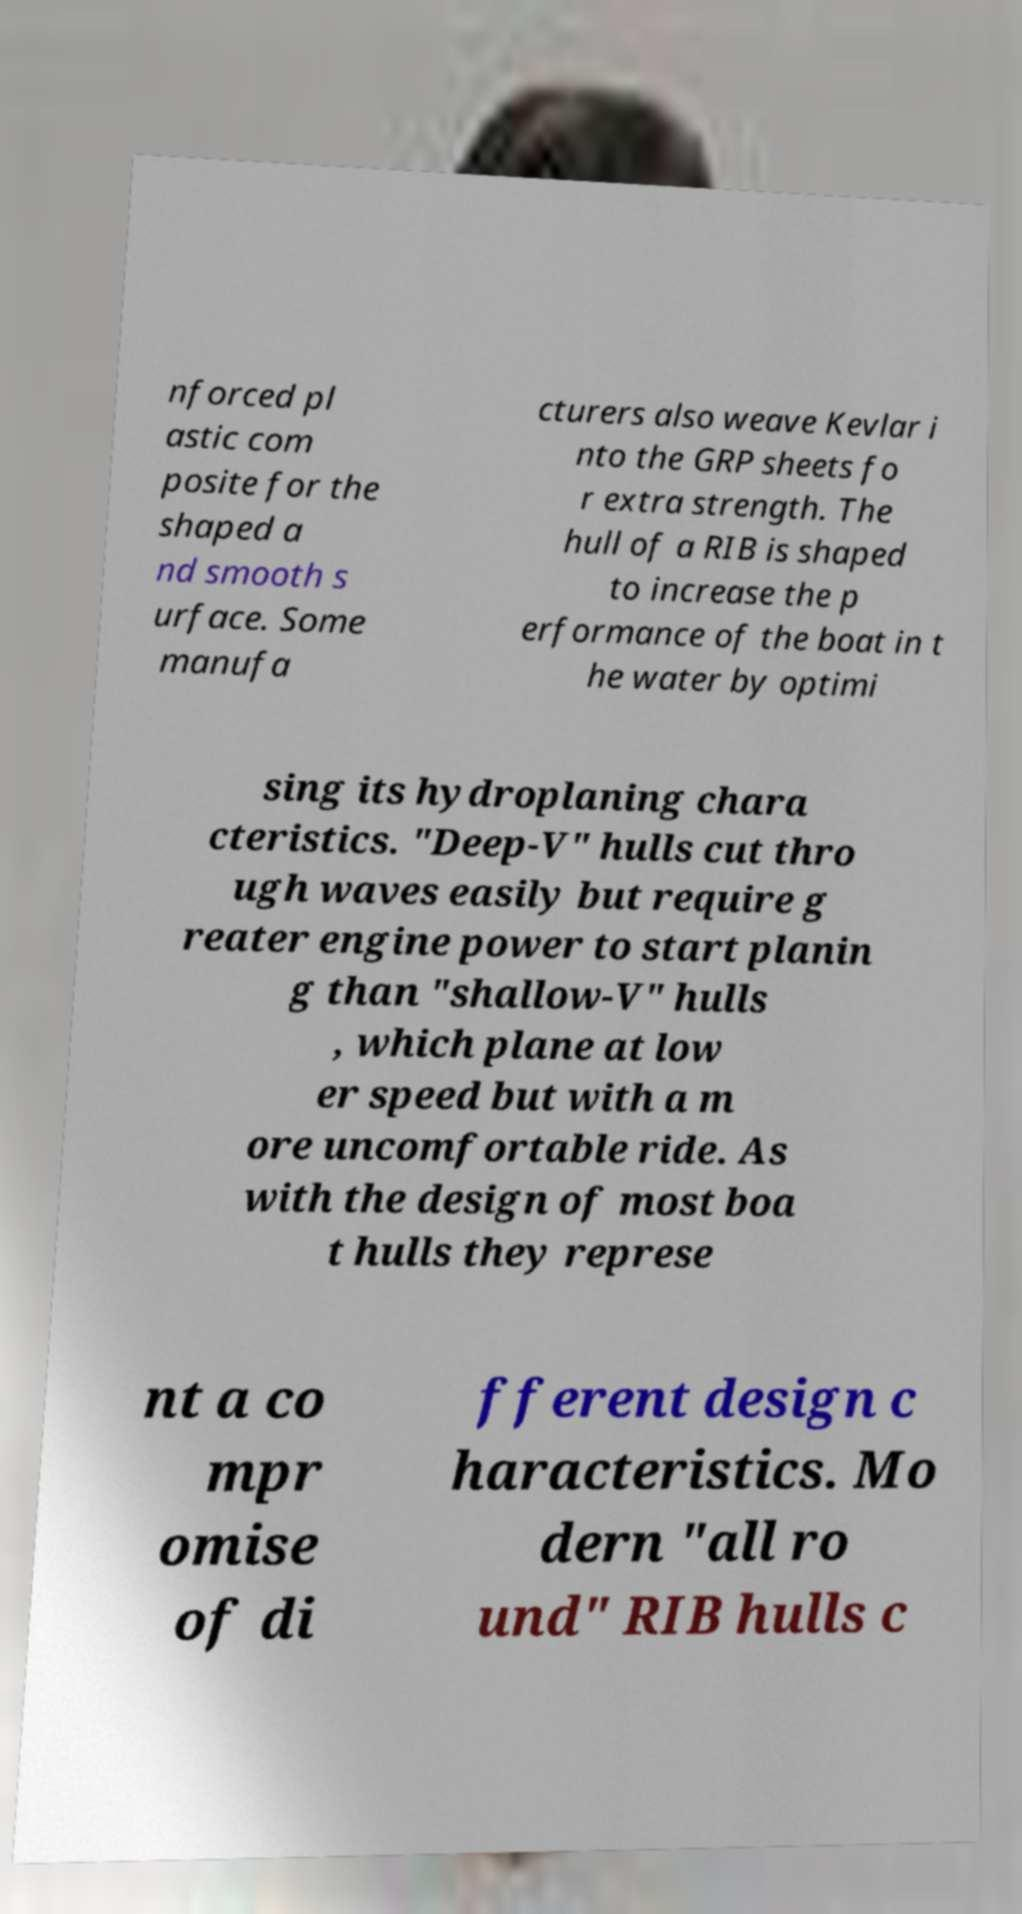Can you accurately transcribe the text from the provided image for me? nforced pl astic com posite for the shaped a nd smooth s urface. Some manufa cturers also weave Kevlar i nto the GRP sheets fo r extra strength. The hull of a RIB is shaped to increase the p erformance of the boat in t he water by optimi sing its hydroplaning chara cteristics. "Deep-V" hulls cut thro ugh waves easily but require g reater engine power to start planin g than "shallow-V" hulls , which plane at low er speed but with a m ore uncomfortable ride. As with the design of most boa t hulls they represe nt a co mpr omise of di fferent design c haracteristics. Mo dern "all ro und" RIB hulls c 